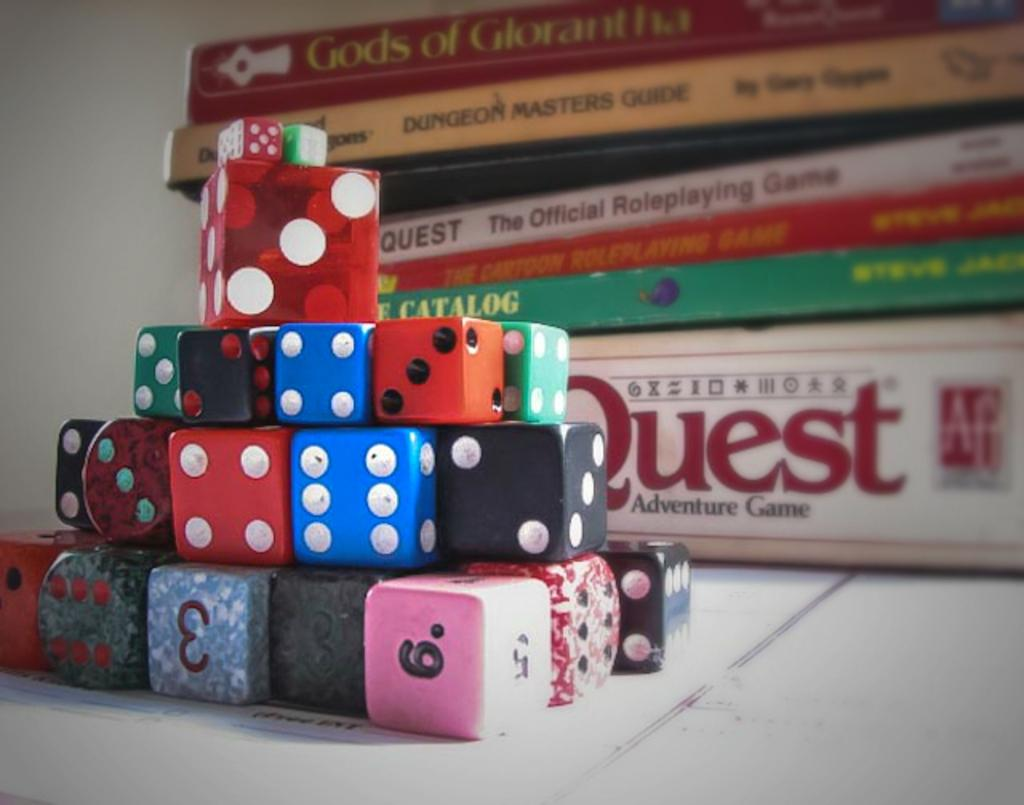Provide a one-sentence caption for the provided image. a bunch of dice in a pile in front of a quest adventure game box. 